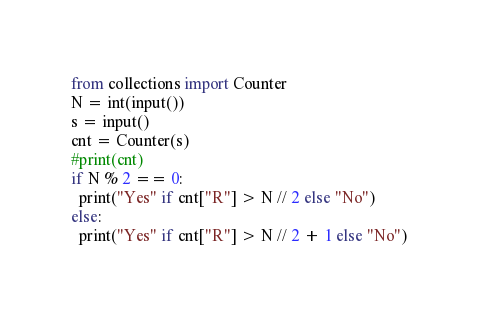<code> <loc_0><loc_0><loc_500><loc_500><_Python_>from collections import Counter
N = int(input())
s = input()
cnt = Counter(s)
#print(cnt)
if N % 2 == 0:
  print("Yes" if cnt["R"] > N // 2 else "No")
else:
  print("Yes" if cnt["R"] > N // 2 + 1 else "No")</code> 